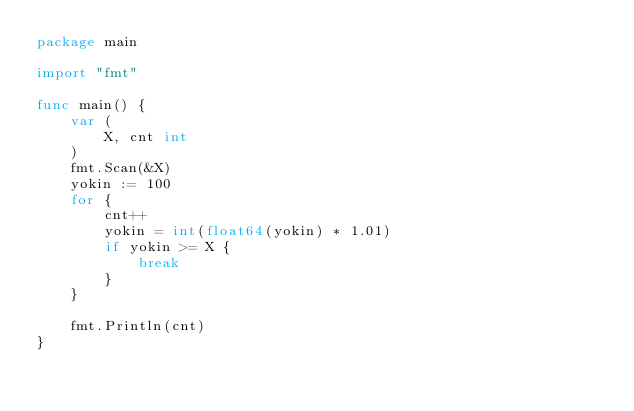<code> <loc_0><loc_0><loc_500><loc_500><_Go_>package main

import "fmt"

func main() {
	var (
		X, cnt int
	)
	fmt.Scan(&X)
	yokin := 100
	for {
		cnt++
		yokin = int(float64(yokin) * 1.01)
		if yokin >= X {
			break
		}
	}

	fmt.Println(cnt)
}</code> 